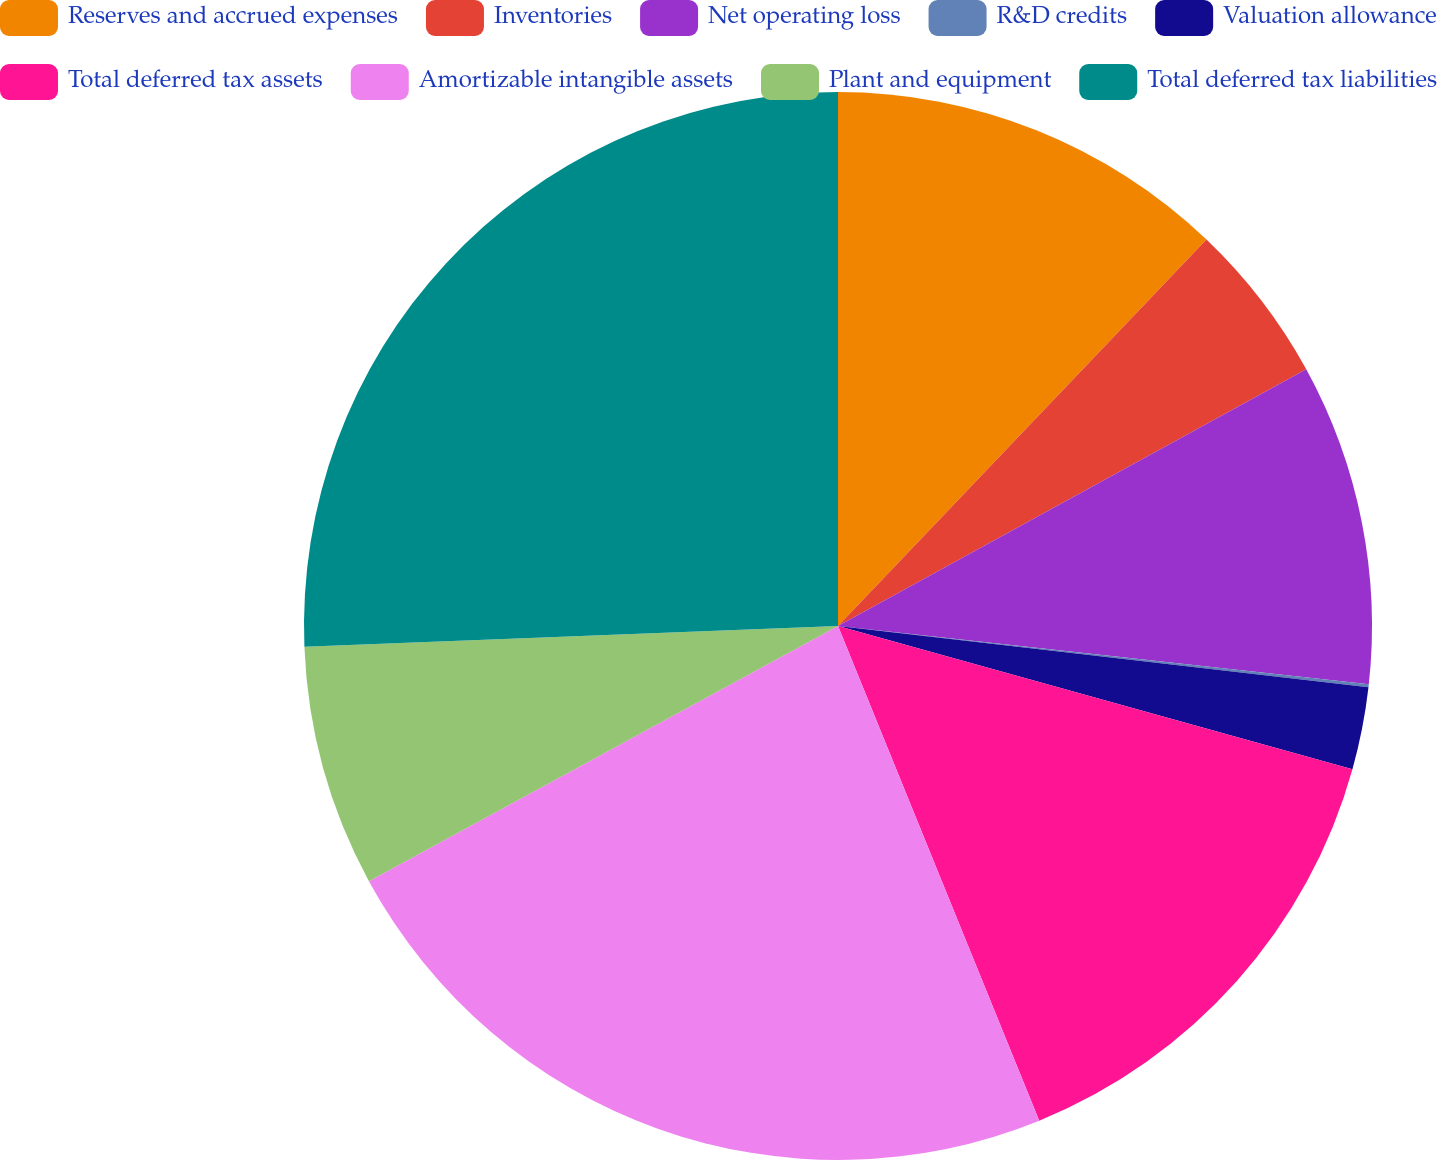Convert chart. <chart><loc_0><loc_0><loc_500><loc_500><pie_chart><fcel>Reserves and accrued expenses<fcel>Inventories<fcel>Net operating loss<fcel>R&D credits<fcel>Valuation allowance<fcel>Total deferred tax assets<fcel>Amortizable intangible assets<fcel>Plant and equipment<fcel>Total deferred tax liabilities<nl><fcel>12.12%<fcel>4.9%<fcel>9.72%<fcel>0.09%<fcel>2.49%<fcel>14.53%<fcel>23.22%<fcel>7.31%<fcel>25.62%<nl></chart> 